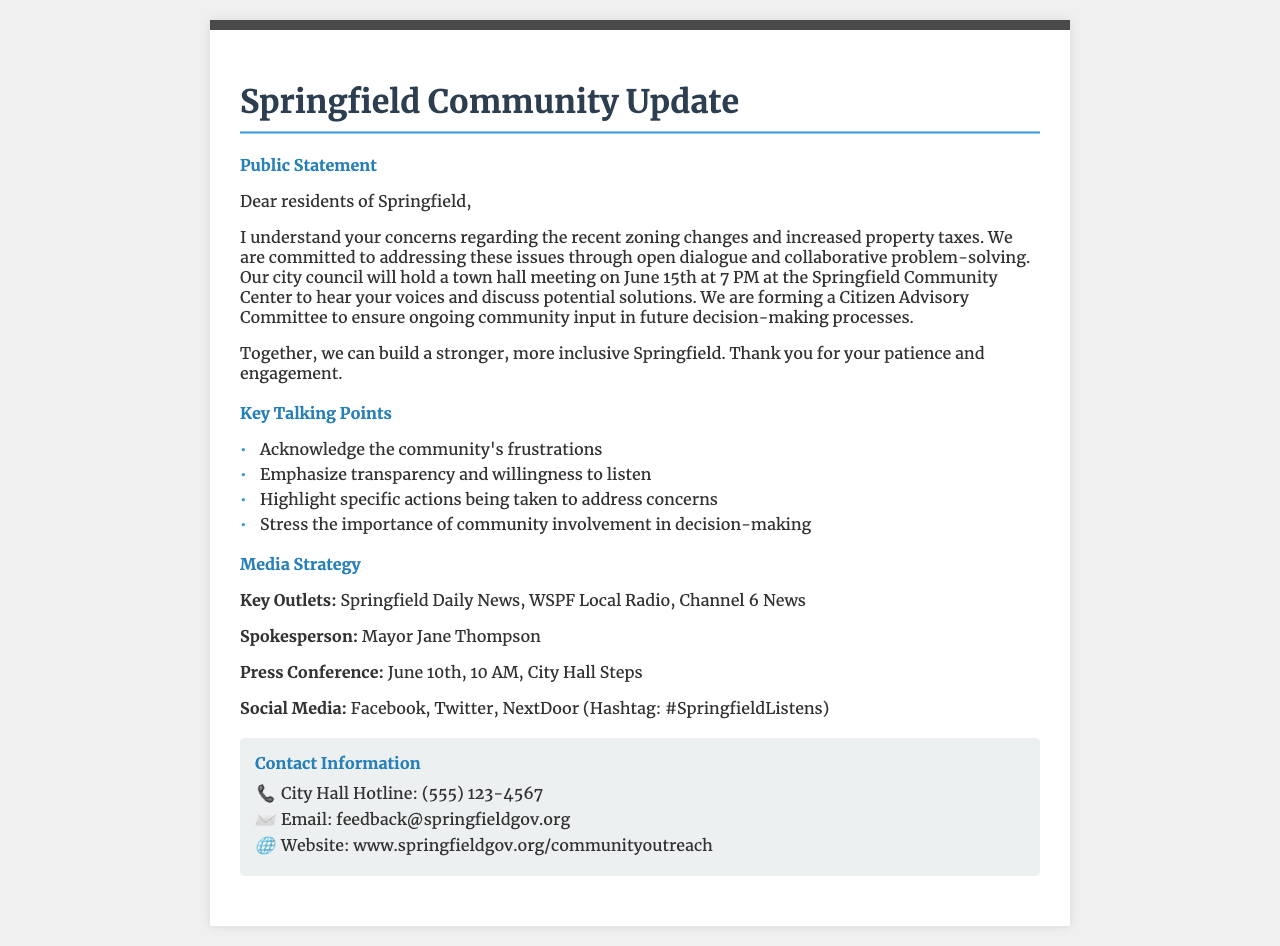what is the date of the town hall meeting? The town hall meeting is scheduled for June 15th, which is mentioned in the public statement section.
Answer: June 15th who is the spokesperson for the media strategy? The document identifies Mayor Jane Thompson as the spokesperson in the media strategy section.
Answer: Mayor Jane Thompson where can residents give feedback? The email address provided in the contact information section is designated for feedback.
Answer: feedback@springfieldgov.org what is the purpose of the Citizen Advisory Committee? The Citizen Advisory Committee is mentioned to ensure ongoing community input in future decision-making processes.
Answer: Community input when is the press conference scheduled? The press conference is scheduled for June 10th, which is specified in the media strategy section.
Answer: June 10th what are the key social media platforms mentioned? The document lists Facebook, Twitter, and NextDoor as the key social media platforms for outreach.
Answer: Facebook, Twitter, NextDoor how is community involvement emphasized? Community involvement is stressed as a critical aspect in the key talking points of the document.
Answer: Importance of community involvement what is the main issue addressed in the public statement? The main issue refers to concerns regarding recent zoning changes and increased property taxes as stated in the public statement.
Answer: Zoning changes and property taxes 